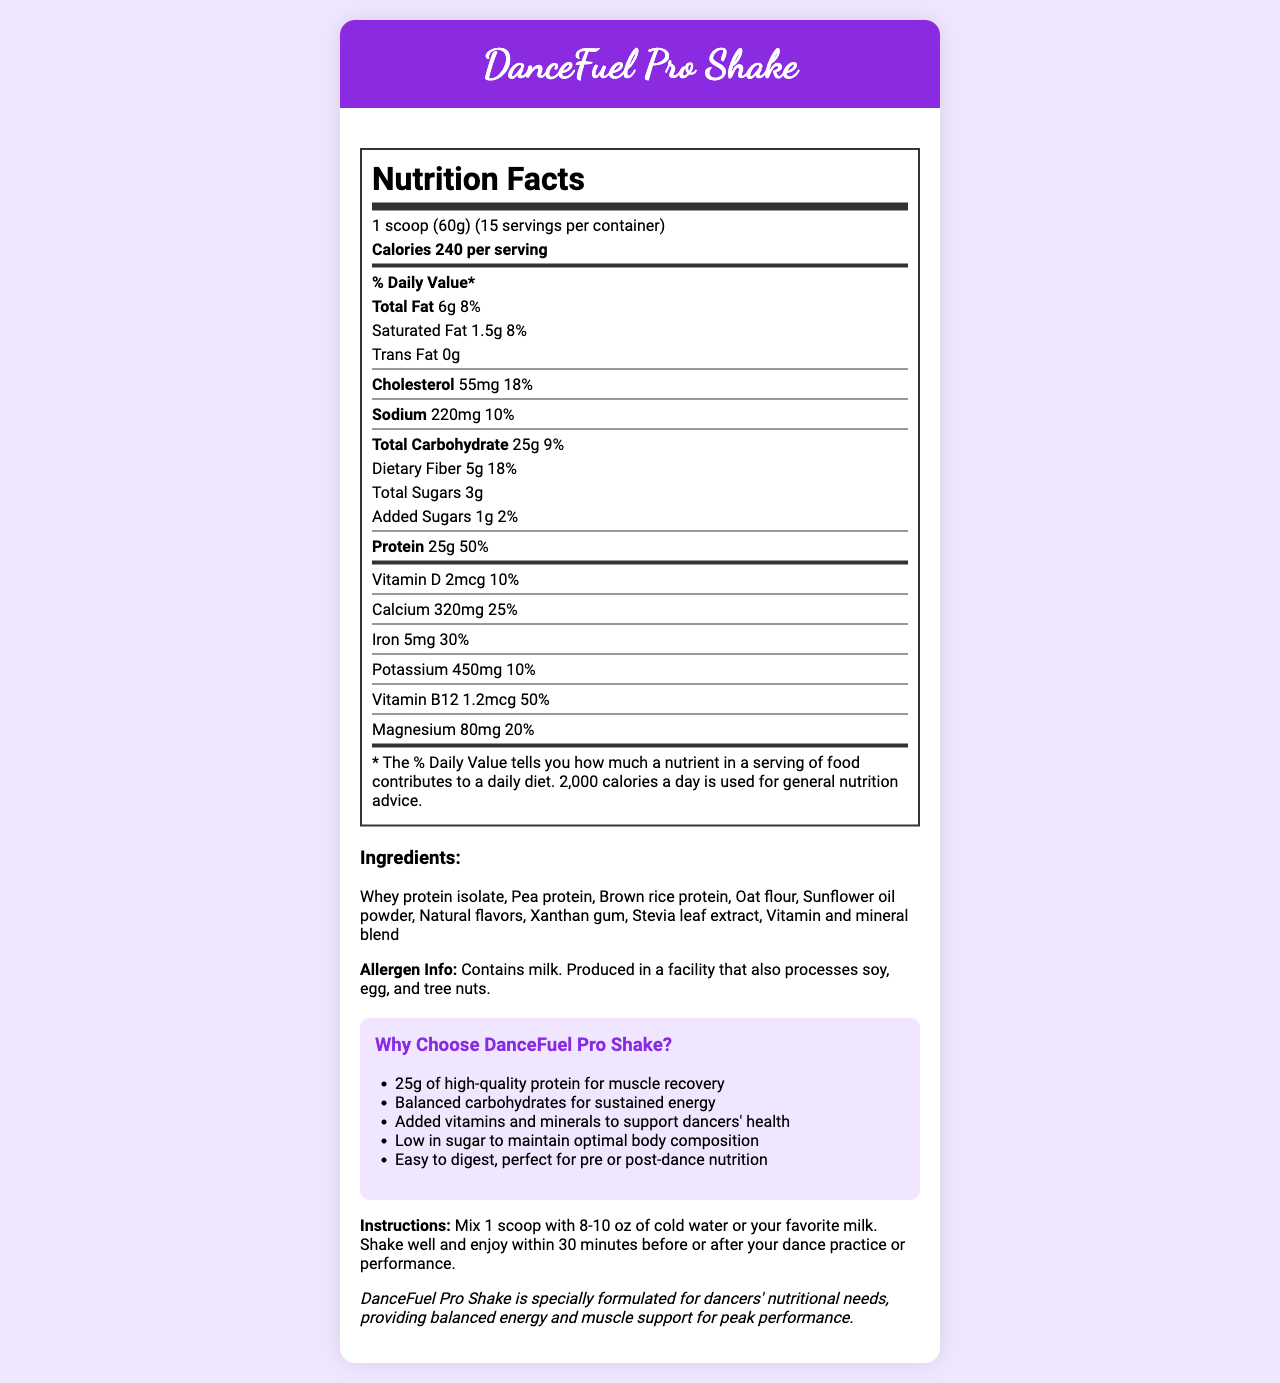what is the serving size? The serving size is listed directly on the Nutrition Facts Label.
Answer: 1 scoop (60g) how many calories are in one serving? The number of calories per serving is stated on the Nutrition Facts Label as 240.
Answer: 240 what is the total amount of fat per serving? The total amount of fat per serving is mentioned as 6 grams in the document.
Answer: 6g how much protein is there per serving, and what percentage of the daily value does it represent? The protein content is listed as 25 grams per serving, which represents 50% of the daily value.
Answer: 25g, 50% what is the allergen information for this product? The allergen information is explicitly mentioned under the ingredients section.
Answer: Contains milk. Produced in a facility that also processes soy, egg, and tree nuts. what is the recommended way to consume DanceFuel Pro Shake for optimal benefits? A. Mix with hot water B. Mix with 8-10 oz of cold water C. Mix with soda The instructions specify mixing 1 scoop with 8-10 oz of cold water or your favorite milk.
Answer: B which vitamin has the highest daily value percentage in this shake? A. Vitamin D B. Calcium C. Vitamin B12 Vitamin B12 has the highest daily value percentage at 50%, which is the same as the protein daily value percentage.
Answer: C does this product contain any trans fat? The document clearly states that trans fat content is 0 grams.
Answer: No is DanceFuel Pro Shake suitable for individuals avoiding added sugars? There is only 1 gram of added sugars per serving, and it represents 2% of the daily value, which is relatively low.
Answer: Yes summarize the main selling points of DanceFuel Pro Shake. The main selling points highlight the high protein content, balanced energy, additional vitamins and minerals, low sugar levels, and ease of digestion, making it ideal for dancers.
Answer: 25g of high-quality protein for muscle recovery, Balanced carbohydrates for sustained energy, Added vitamins and minerals to support dancers' health, Low in sugar to maintain optimal body composition, Easy to digest, perfect for pre or post-dance nutrition. can this document tell you the storage instructions for DanceFuel Pro Shake? The document provides mixing and consumption instructions but does not mention how to store the product.
Answer: Not enough information 